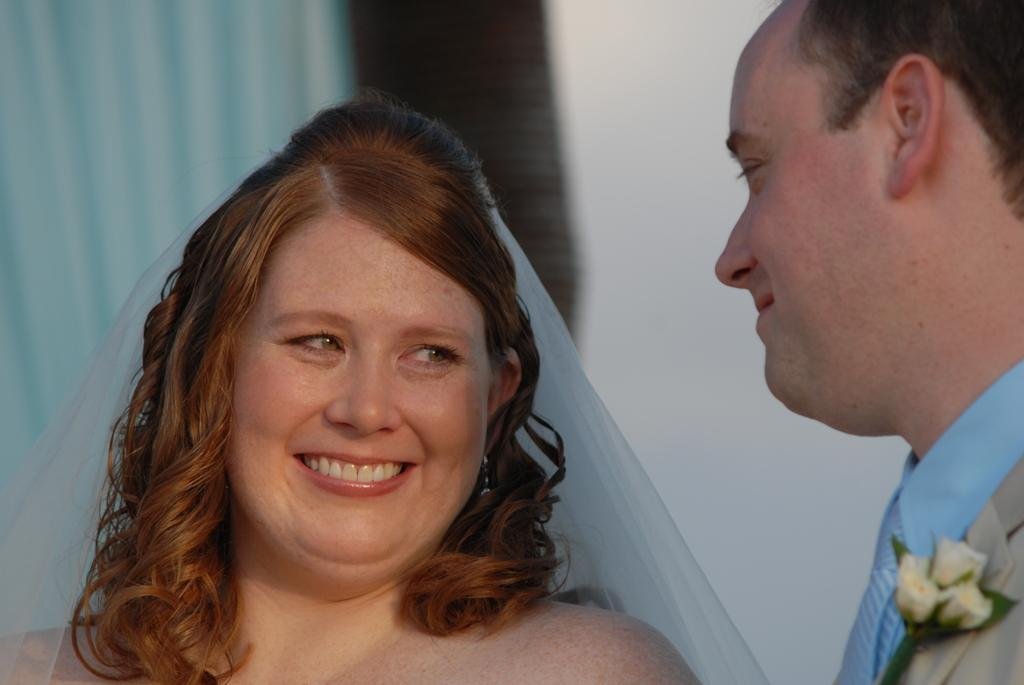Who are the people in the image? There is a couple in the image. What is the man wearing? The man is wearing a blue color shirt and a gray color suit. What other object can be seen in the image? There is a flower in the image. What type of basket is being used to hold the thread in the image? There is no basket or thread present in the image. What thrilling activity is the couple participating in during the image? The image does not depict any specific activity or thrill; it simply shows a couple and a flower. 